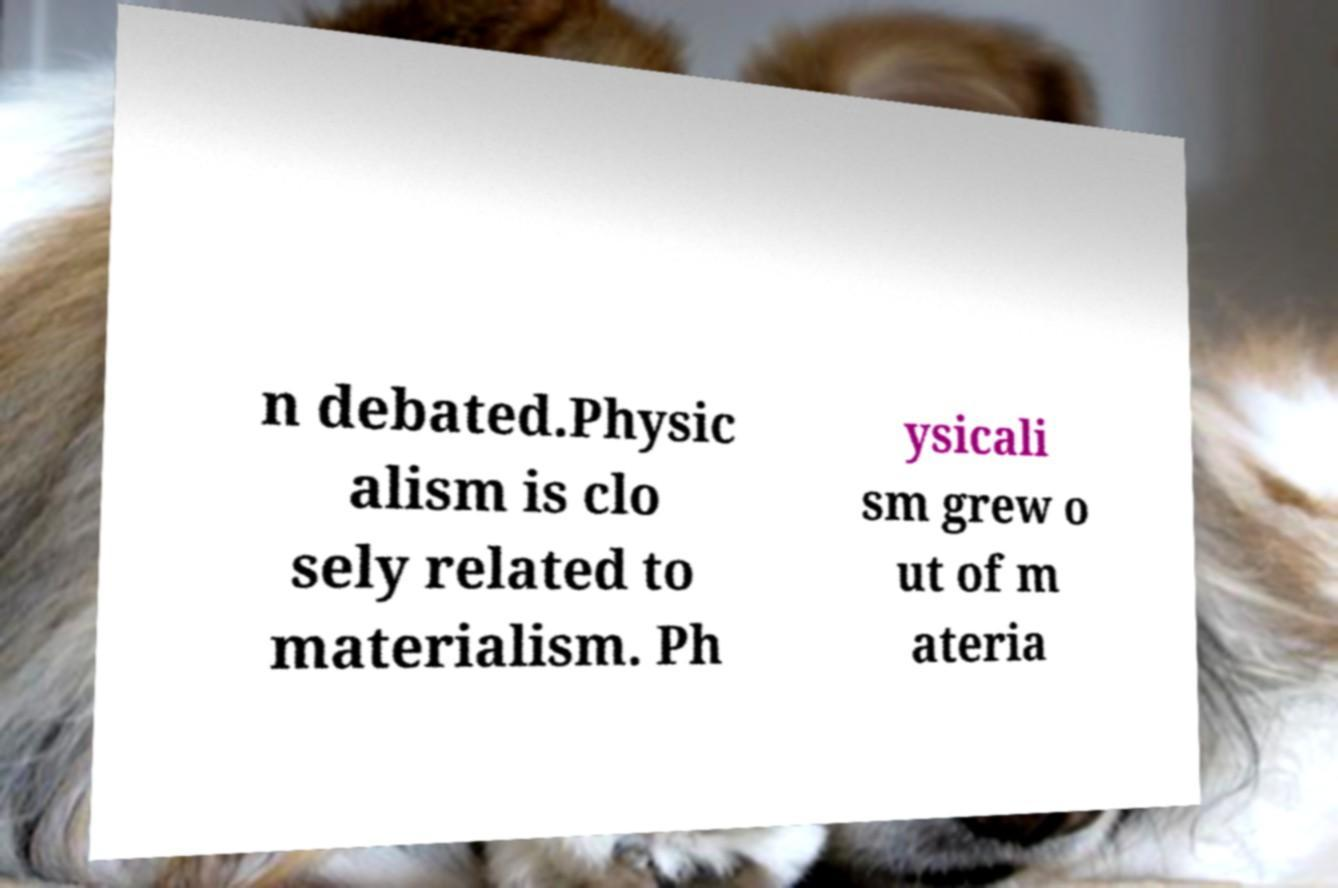Please read and relay the text visible in this image. What does it say? n debated.Physic alism is clo sely related to materialism. Ph ysicali sm grew o ut of m ateria 